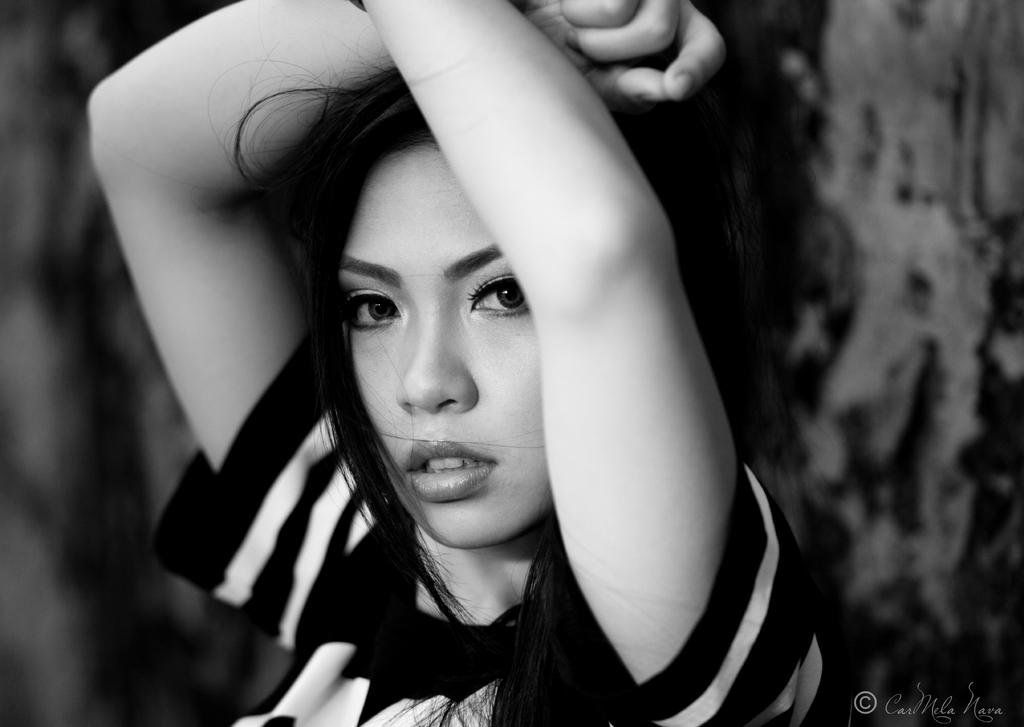What is the color scheme of the image? The image is black and white. Can you describe the main subject of the image? There is a woman in the image. What type of soup is the woman holding in the image? There is no soup present in the image; it is a black and white image featuring a woman. What type of stocking is the woman wearing in the image? There is no information about the woman's stockings in the image, as it is black and white and focused on the woman's presence. 